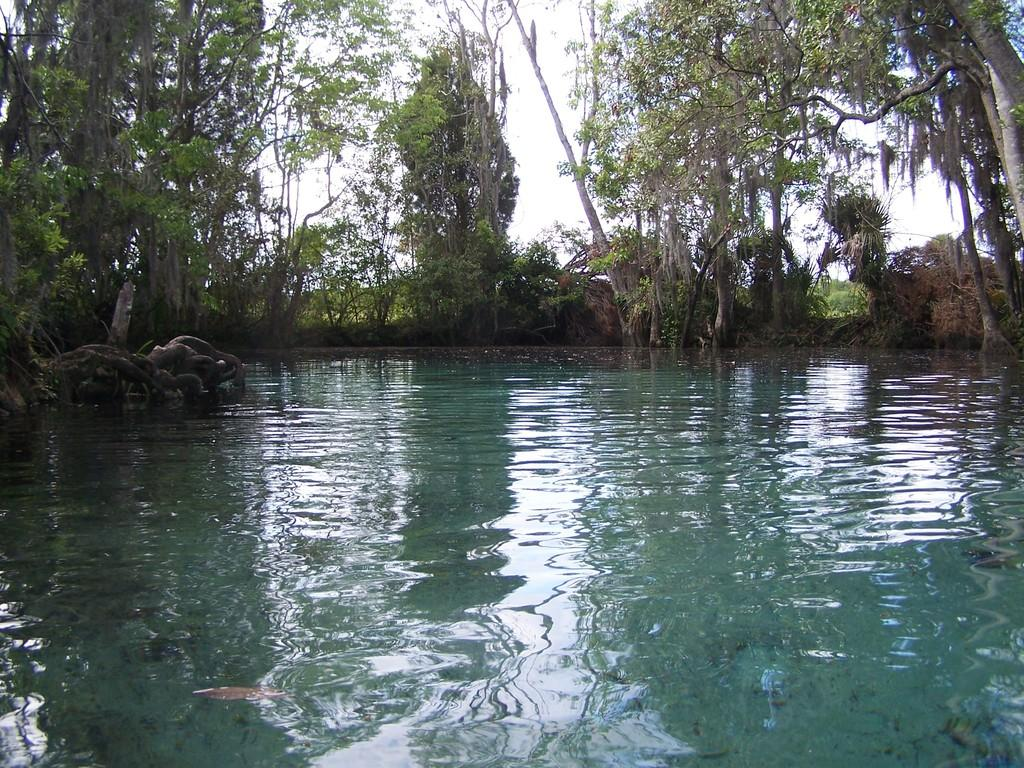What is present in the image that is not solid? There is water in the image. What type of vegetation can be seen in the image? There are trees in the image. What can be seen in the background of the image? The sky is visible in the background of the image. Where is the doctor standing in the image? There is no doctor present in the image. What type of cake is being served in the image? There is no cake present in the image. 